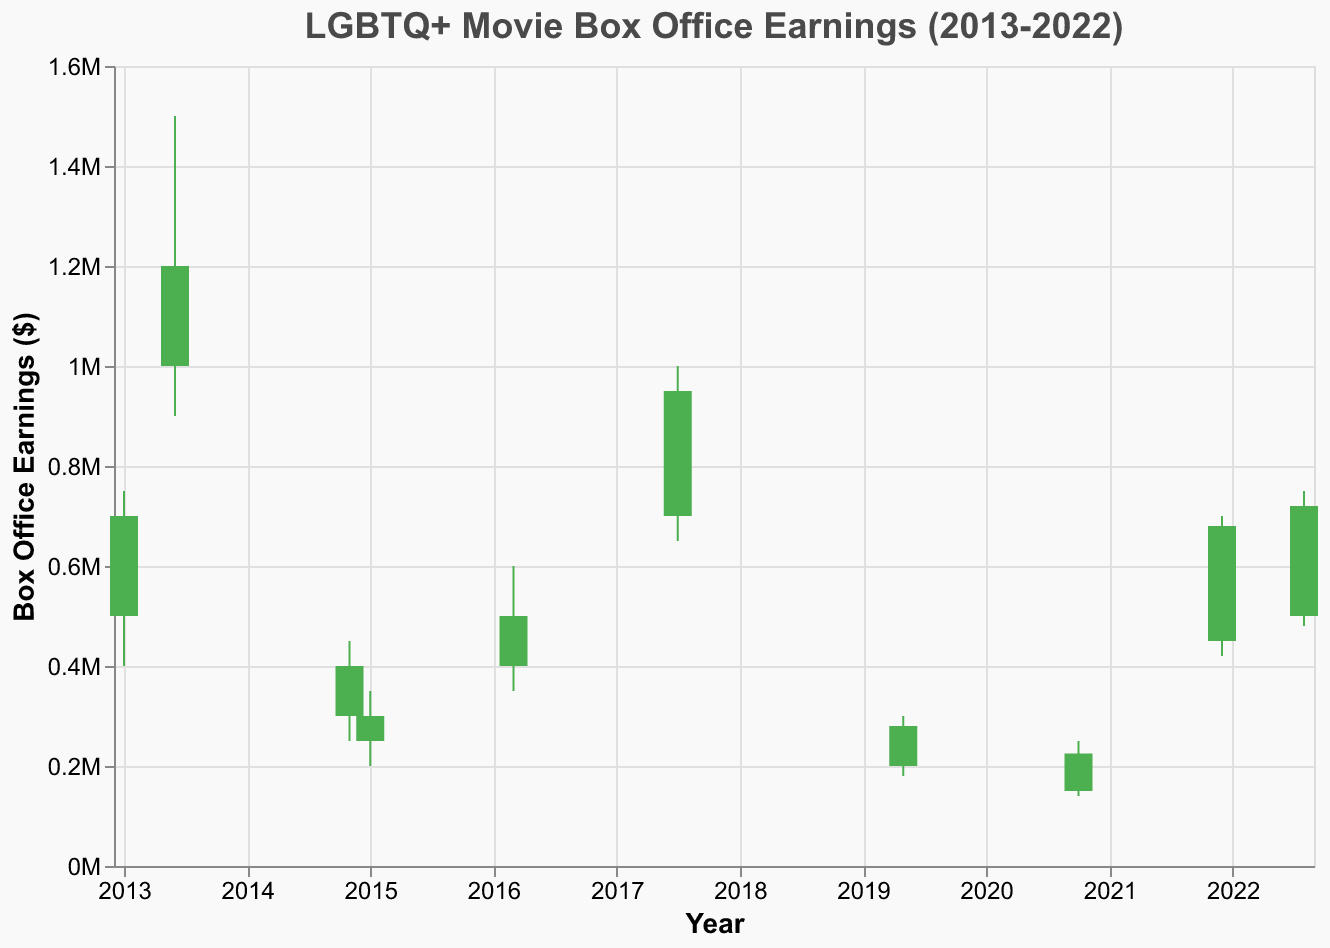what is the title of the figure? The title is at the top of the figure and reads "LGBTQ+ Movie Box Office Earnings (2013-2022)".
Answer: LGBTQ+ Movie Box Office Earnings (2013-2022) How many data points are plotted in the figure? By counting all the data entries, we find there are 10 points, each representing a different movie.
Answer: 10 Which movie had the highest monthly box office earnings? "Blue Is the Warmest Color" has the highest 'High' value, which is $1,500,000, as indicated by the tallest endpoint of the lines.
Answer: Blue Is the Warmest Color What movie saw its earnings increase the most within a month? Look for the green bars since they show movies where the closing value is higher than the opening. Among them, "Blue Is the Warmest Color" had the largest difference, with an opening of $1,000,000 and a closing of $1,200,000.
Answer: Blue Is the Warmest Color Which year had the highest initial box office earnings for any LGBTQ+ movie? "Blue Is the Warmest Color" in June 2013 had the highest opening value of $1,000,000.
Answer: 2013 What was the opening box office earning for "Fire Island"? "Fire Island" opened with $500,000 as shown in the data legend for the movie title "Fire Island".
Answer: $500,000 Which movies closed lower than they opened? "Pride", "Carol", "Moonlight", and "Portrait of a Lady on Fire" have red bars, indicating a lower closing value than opening value.
Answer: Pride, Carol, Moonlight, Portrait of a Lady on Fire What is the average 'High' value for all the listed movies? Sum of 'High' values: 750000 + 1500000 + 450000 + 350000 + 600000 + 1000000 + 300000 + 250000 + 700000 + 750000 = 6650000. Average = 6650000 / 10 = 665000.
Answer: 665000 Compare the difference between the 'High' and 'Low' values of "Call Me by Your Name" and "The Way He Looks." Which one had a larger range? "Call Me by Your Name": 1000000 - 650000 = 350000; "The Way He Looks": 750000 - 400000 = 350000; Both movies had the same range of 350000.
Answer: Both had the same range How many movies earned more than $600,000 in their worst box office month? Scan through 'Low' values and count those greater than $600,000. Only "Blue Is the Warmest Color" has a low value of $900,000.
Answer: 1 